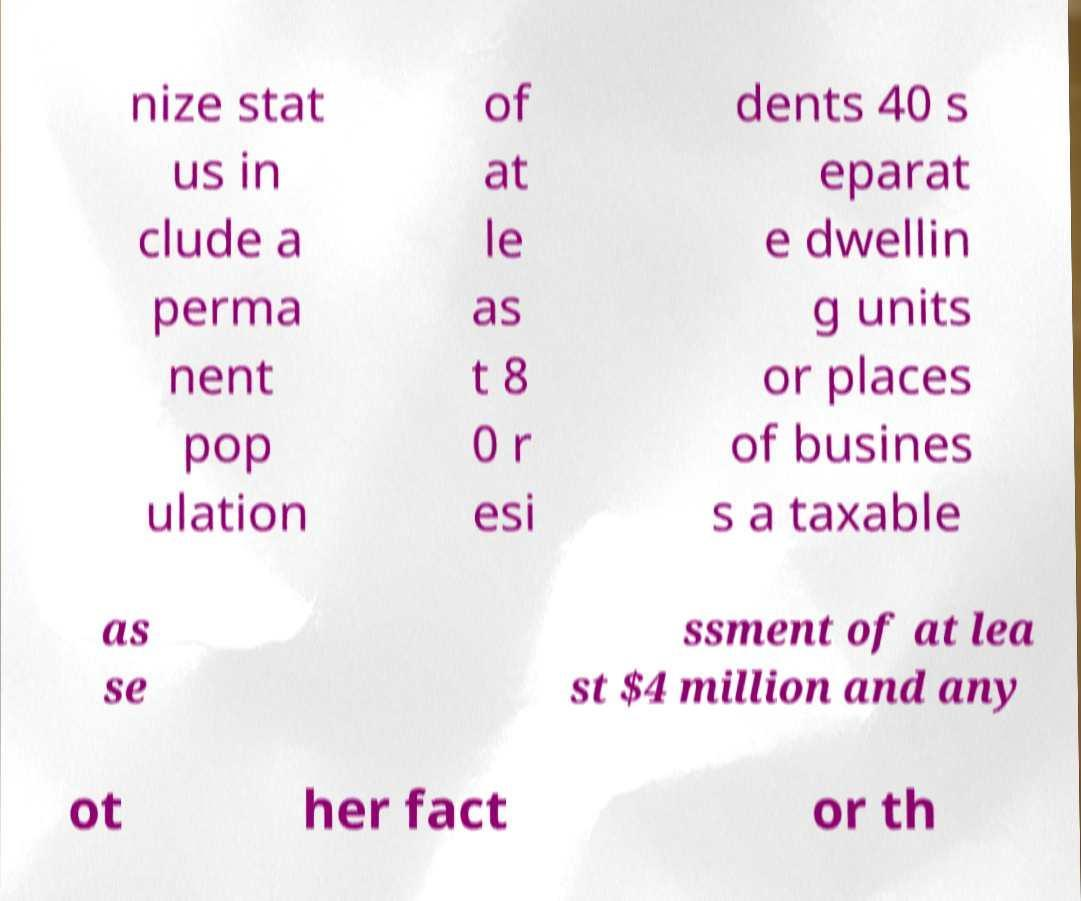Could you extract and type out the text from this image? nize stat us in clude a perma nent pop ulation of at le as t 8 0 r esi dents 40 s eparat e dwellin g units or places of busines s a taxable as se ssment of at lea st $4 million and any ot her fact or th 